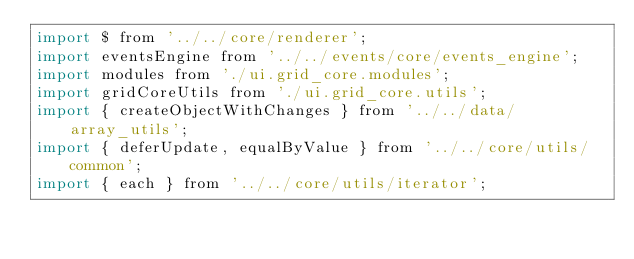Convert code to text. <code><loc_0><loc_0><loc_500><loc_500><_JavaScript_>import $ from '../../core/renderer';
import eventsEngine from '../../events/core/events_engine';
import modules from './ui.grid_core.modules';
import gridCoreUtils from './ui.grid_core.utils';
import { createObjectWithChanges } from '../../data/array_utils';
import { deferUpdate, equalByValue } from '../../core/utils/common';
import { each } from '../../core/utils/iterator';</code> 